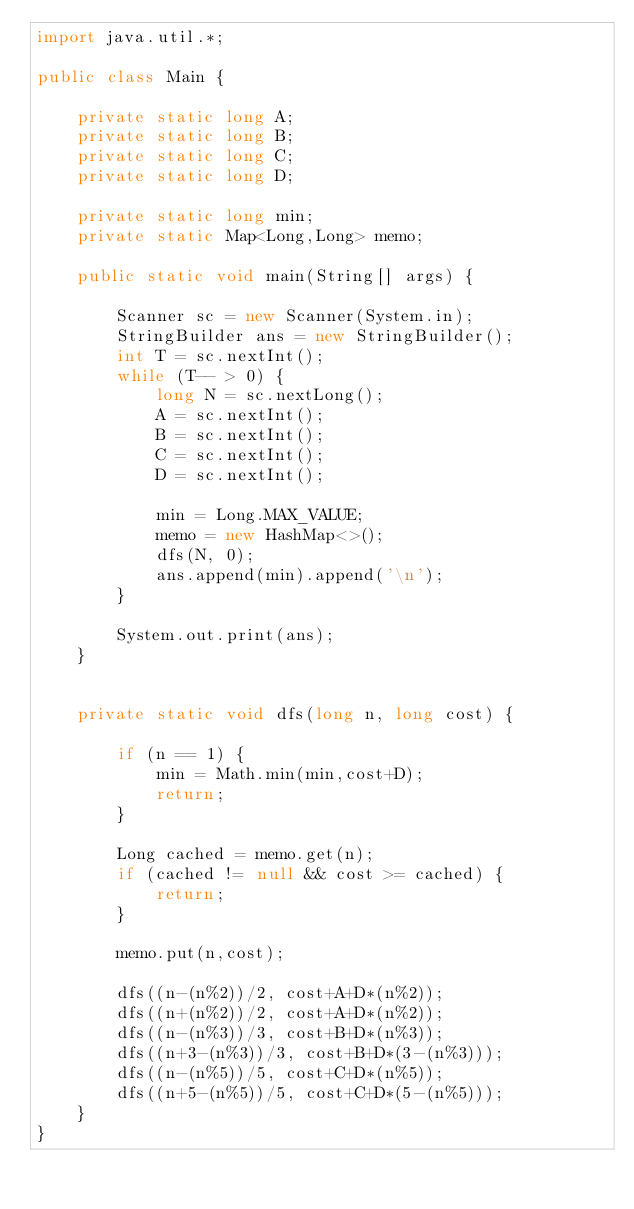<code> <loc_0><loc_0><loc_500><loc_500><_Java_>import java.util.*;

public class Main {

    private static long A;
    private static long B;
    private static long C;
    private static long D;

    private static long min;
    private static Map<Long,Long> memo;

    public static void main(String[] args) {

        Scanner sc = new Scanner(System.in);
        StringBuilder ans = new StringBuilder();
        int T = sc.nextInt();
        while (T-- > 0) {
            long N = sc.nextLong();
            A = sc.nextInt();
            B = sc.nextInt();
            C = sc.nextInt();
            D = sc.nextInt();

            min = Long.MAX_VALUE;
            memo = new HashMap<>();
            dfs(N, 0);
            ans.append(min).append('\n');
        }

        System.out.print(ans);
    }


    private static void dfs(long n, long cost) {

        if (n == 1) {
            min = Math.min(min,cost+D);
            return;
        }

        Long cached = memo.get(n);
        if (cached != null && cost >= cached) {
            return;
        }

        memo.put(n,cost);

        dfs((n-(n%2))/2, cost+A+D*(n%2));
        dfs((n+(n%2))/2, cost+A+D*(n%2));
        dfs((n-(n%3))/3, cost+B+D*(n%3));
        dfs((n+3-(n%3))/3, cost+B+D*(3-(n%3)));
        dfs((n-(n%5))/5, cost+C+D*(n%5));
        dfs((n+5-(n%5))/5, cost+C+D*(5-(n%5)));
    }
}
</code> 